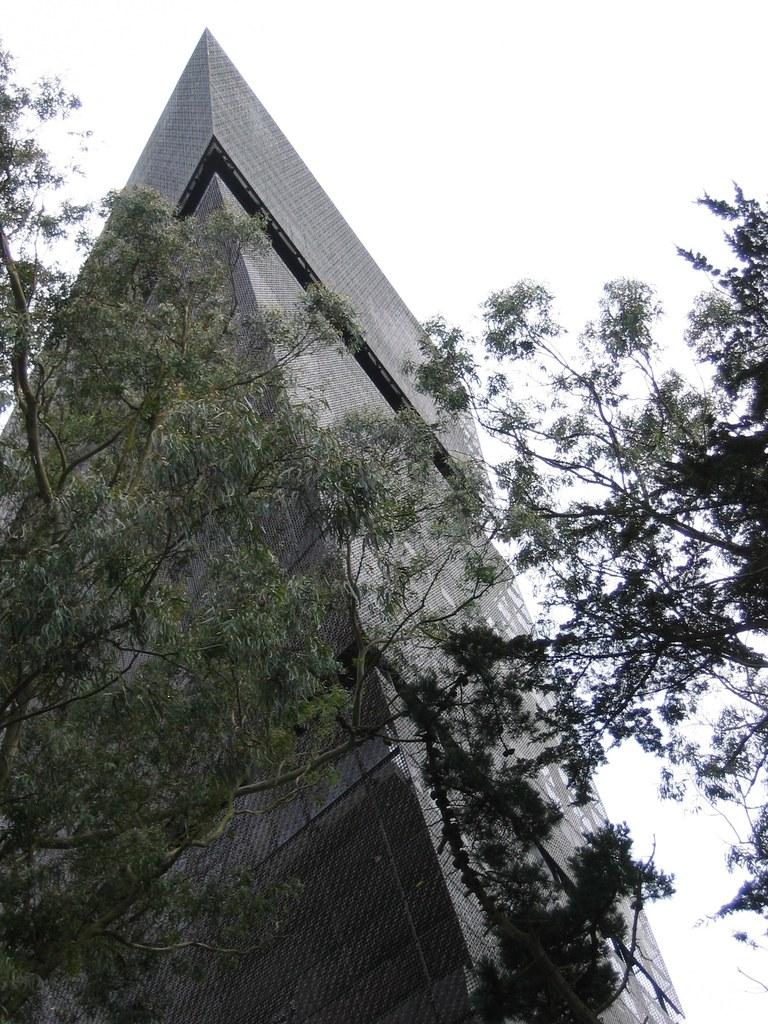What type of structure is present in the image? There is a building in the image. What other natural elements can be seen in the image? There are trees in the image. What part of the environment is visible in the image? The sky is visible in the image. How would you describe the weather based on the sky in the image? The sky appears to be cloudy in the image. How many mailboxes are there in the image? There is no mailbox present in the image. What type of furniture can be seen in the image? There are no chairs or any other furniture visible in the image. 